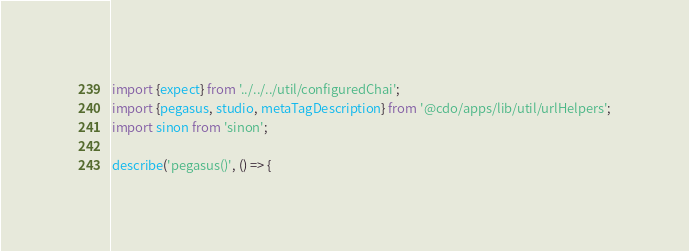Convert code to text. <code><loc_0><loc_0><loc_500><loc_500><_JavaScript_>import {expect} from '../../../util/configuredChai';
import {pegasus, studio, metaTagDescription} from '@cdo/apps/lib/util/urlHelpers';
import sinon from 'sinon';

describe('pegasus()', () => {</code> 